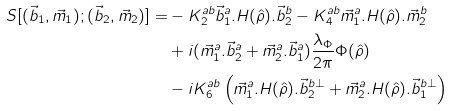Convert formula to latex. <formula><loc_0><loc_0><loc_500><loc_500>S [ ( \vec { b } _ { 1 } , \vec { m } _ { 1 } ) ; ( \vec { b } _ { 2 } , \vec { m } _ { 2 } ) ] = & - K _ { 2 } ^ { a b } \vec { b } _ { 1 } ^ { a } . H ( \hat { \rho } ) . \vec { b } _ { 2 } ^ { b } - K _ { 4 } ^ { a b } \vec { m } _ { 1 } ^ { a } . H ( \hat { \rho } ) . \vec { m } _ { 2 } ^ { b } \\ & + i ( \vec { m } _ { 1 } ^ { a } . \vec { b } _ { 2 } ^ { a } + \vec { m } _ { 2 } ^ { a } . \vec { b } _ { 1 } ^ { a } ) \frac { \lambda _ { \Phi } } { 2 \pi } \Phi ( \hat { \rho } ) \\ & - i K _ { 6 } ^ { a b } \left ( \vec { m } _ { 1 } ^ { a } . H ( \hat { \rho } ) . \vec { b } _ { 2 } ^ { b \perp } + \vec { m } _ { 2 } ^ { a } . H ( \hat { \rho } ) . \vec { b } _ { 1 } ^ { b \perp } \right )</formula> 